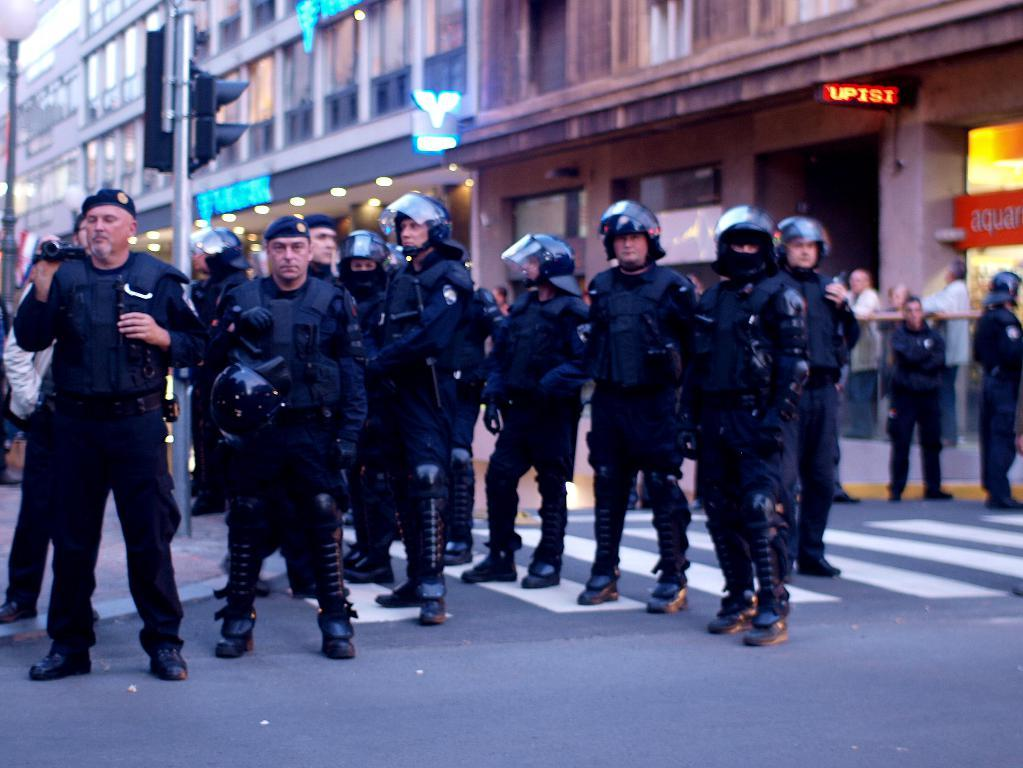What are the people in the image doing? The people in the image are standing on the road. What is located behind the people? There is a traffic signal behind the people. What can be seen in the distance in the image? There are buildings visible in the background. What type of harmony is being played by the people in the image? There is no indication of any musical instruments or harmony in the image; the people are simply standing on the road. 